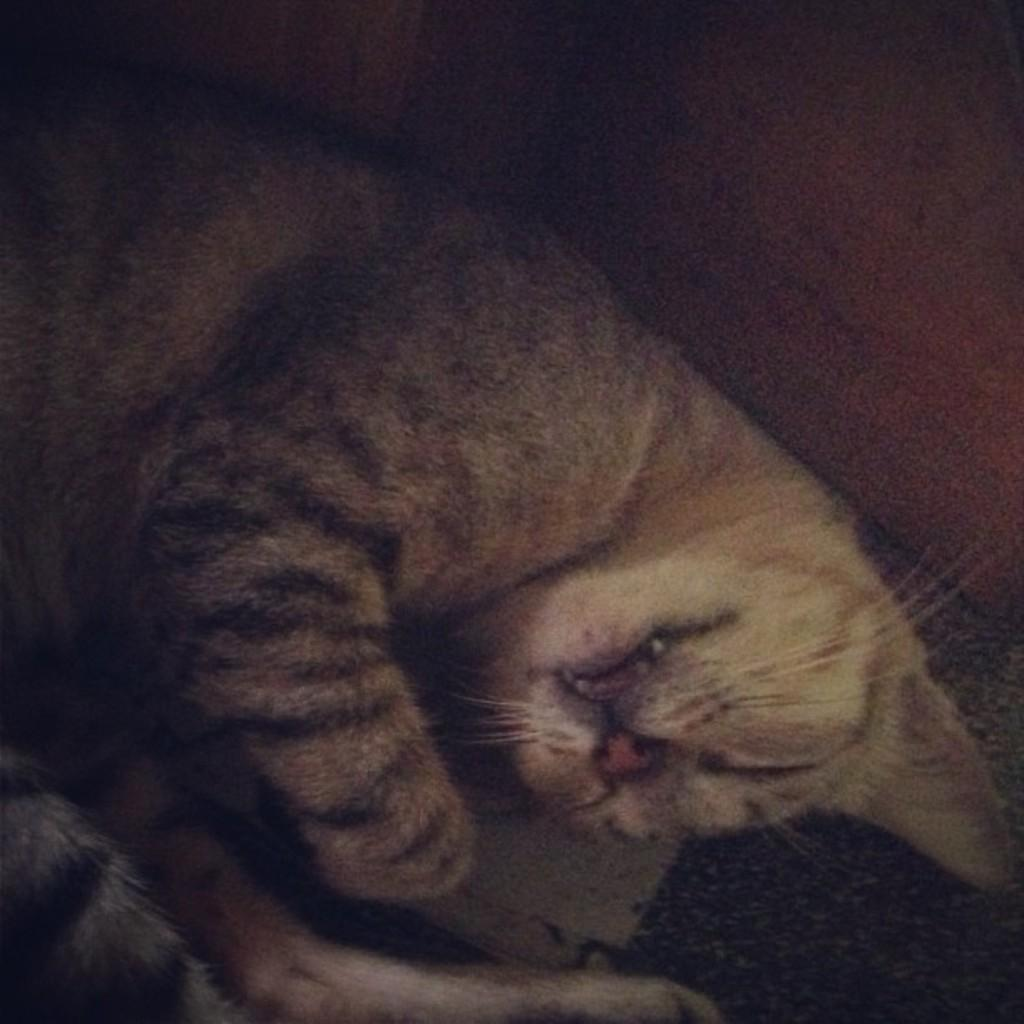What type of animal is present in the image? There is a cat in the image. What is the cat doing in the image? The cat is lying on the floor. What type of cream is being used to decorate the yam in the image? There is no yam or cream present in the image; it only features a cat lying on the floor. 